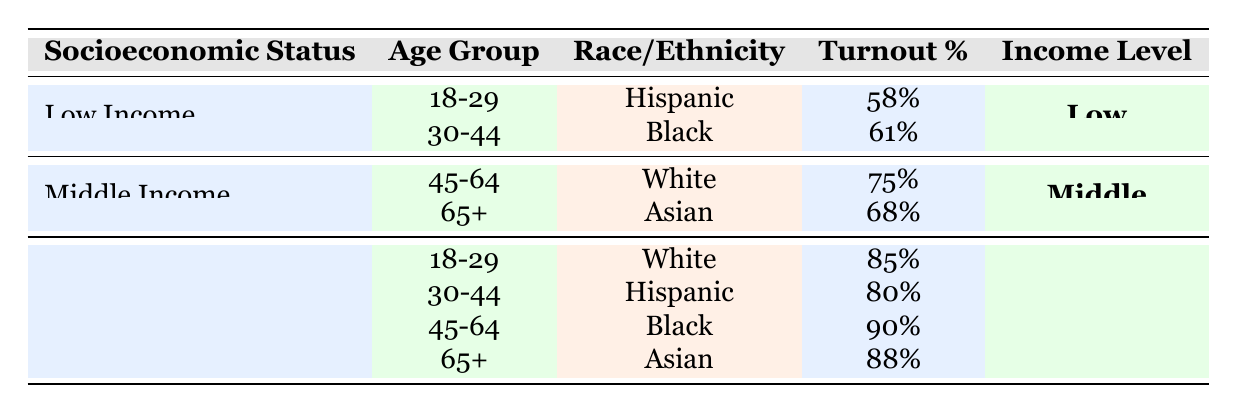What was the voter turnout percentage for Low Income individuals aged 18-29? The table shows that for the Low Income group and the age group of 18-29, the turnout percentage is listed as 58%.
Answer: 58% What is the highest voter turnout percentage among the High Income group? The table displays the turnout percentages for the High Income group. The highest turnout percentage is 90% for the 45-64 age group.
Answer: 90% Is the voter turnout for Middle Income Asians aged 65+ higher than that of Low Income Blacks aged 30-44? The Middle Income Asians aged 65+ have a turnout percentage of 68%, while Low Income Blacks aged 30-44 have a turnout percentage of 61%. Since 68% is greater than 61%, the statement is true.
Answer: Yes What is the average turnout percentage for the High Income demographic across all age groups? The turnout percentages for the High Income group are 85%, 80%, 90%, and 88%. First, sum these values: 85 + 80 + 90 + 88 = 343. Divide the total by the number of age groups (4) to find the average: 343 / 4 = 85.75%.
Answer: 85.75% How many voter turnout percentages in the table are 80% or higher? The turnout percentages that meet or exceed 80% are 85%, 80%, 90%, and 88%. Therefore, there are four percentages in total that are 80% or higher.
Answer: 4 What is the voter turnout percentage for Middle Income individuals aged 45-64? According to the table, the voter turnout percentage for Middle Income individuals in the 45-64 age group is 75%.
Answer: 75% Are there more Low Income age groups with a turnout percentage below 60% compared to those above 60%? There are two Low Income age groups: 18-29 with 58% and 30-44 with 61%. One of these groups has a turnout below 60%, while the other is above 60%. Thus, there is one group below and one group above, making this statement false.
Answer: No What is the difference in turnout percentage between High Income Whites aged 18-29 and Low Income Hispanics aged 18-29? The turnout percentage for High Income Whites aged 18-29 is 85%, whereas for Low Income Hispanics aged 18-29 it is 58%. The difference is 85 - 58 = 27%.
Answer: 27% 